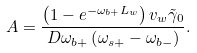Convert formula to latex. <formula><loc_0><loc_0><loc_500><loc_500>A = \frac { \left ( 1 - e ^ { - \omega _ { b + } L _ { w } } \right ) v _ { w } \tilde { \gamma } _ { 0 } } { D \omega _ { b + } \left ( \omega _ { s + } - \omega _ { b - } \right ) } .</formula> 